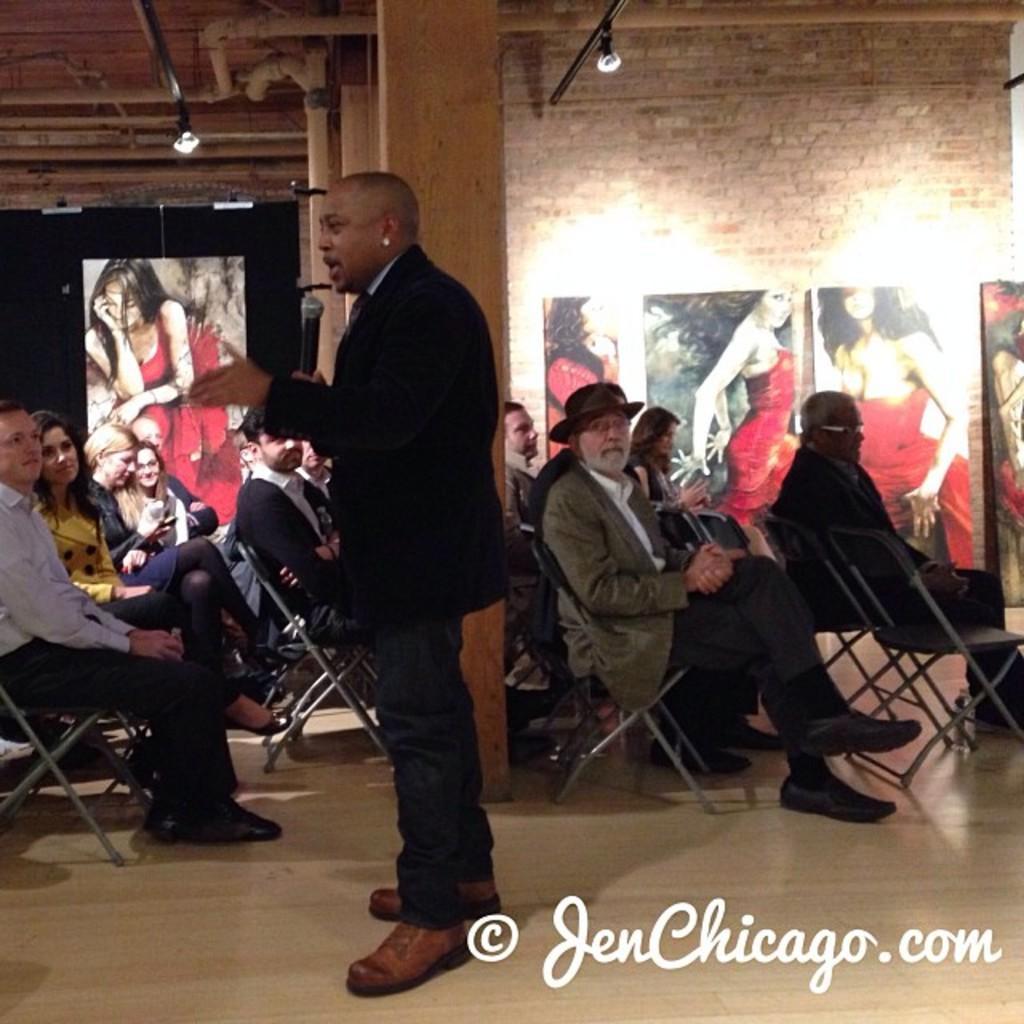In one or two sentences, can you explain what this image depicts? In this image there is a person standing and speaking in a mic, beside the person there are a few people seated on chairs, beside them there are a few posters on the wall. 